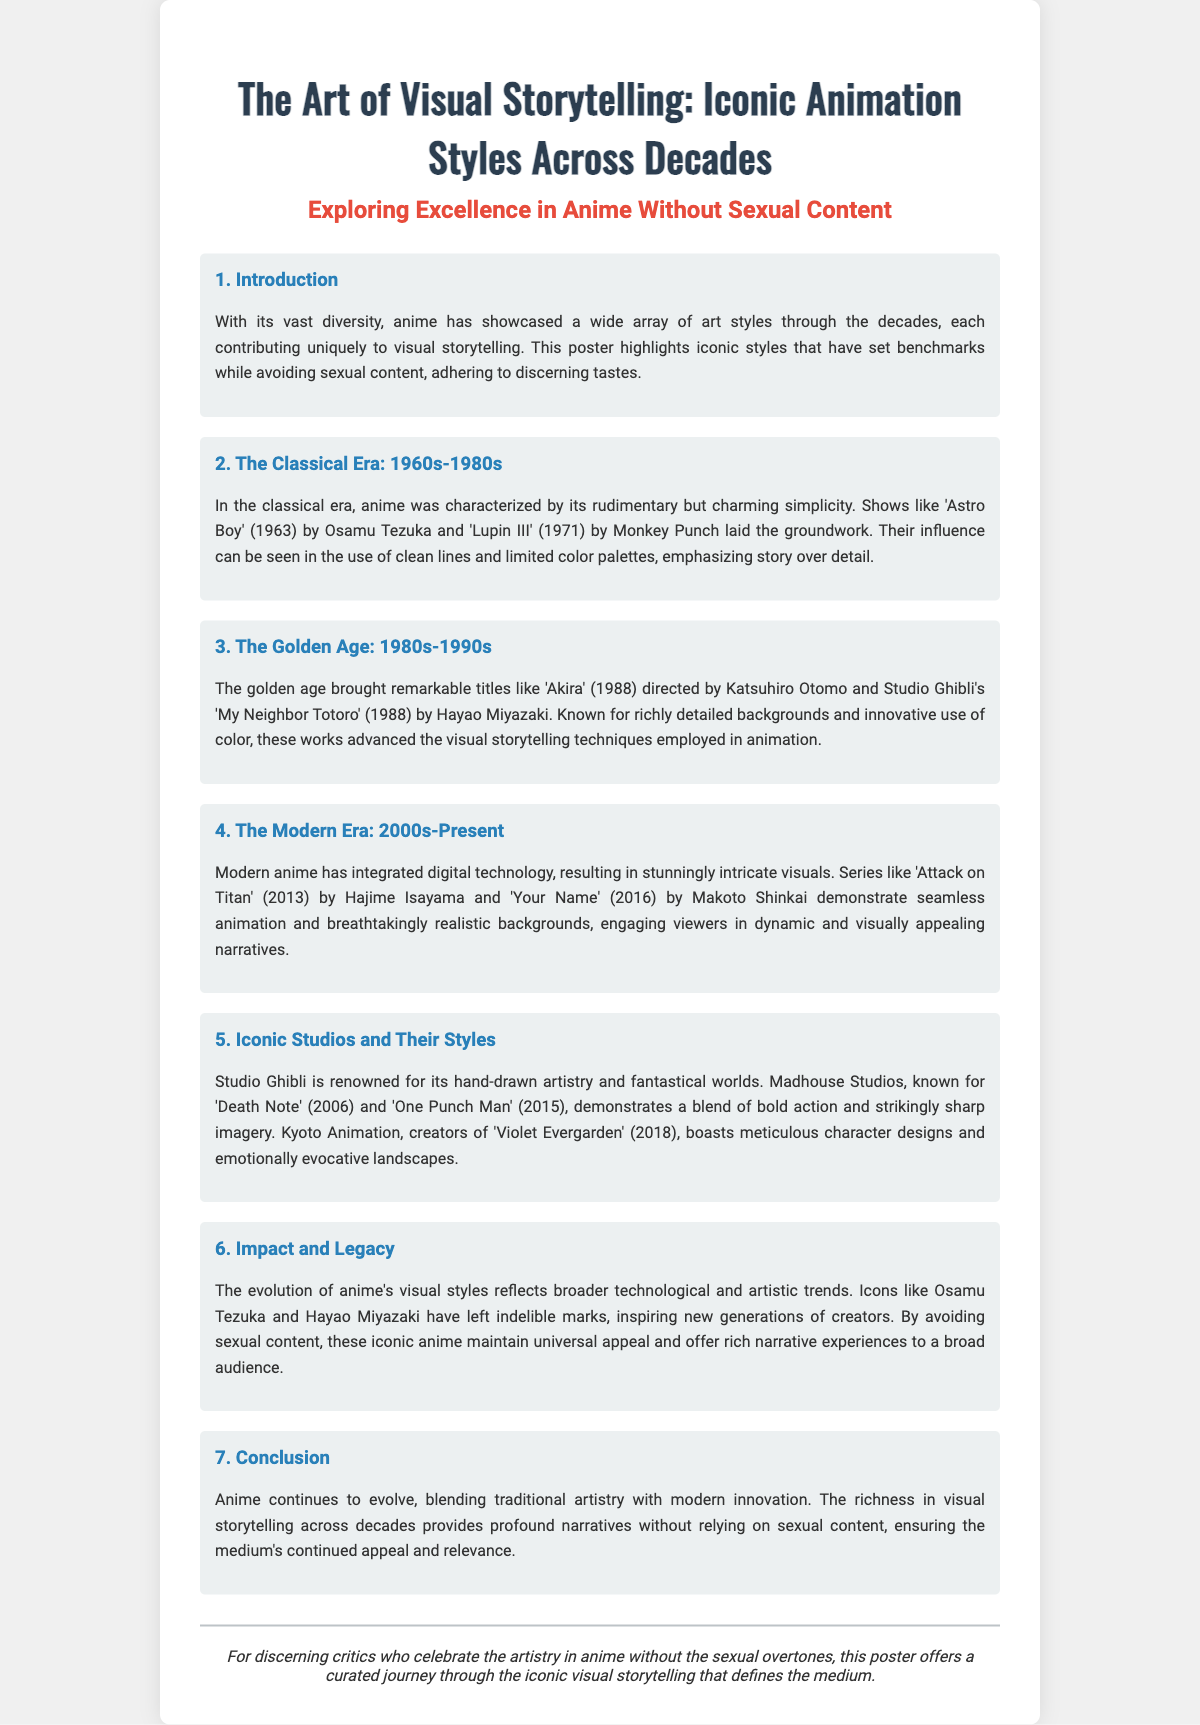What is the title of the poster? The title of the poster is stated at the top of the document.
Answer: The Art of Visual Storytelling: Iconic Animation Styles Across Decades What decades does the classical era cover? The classical era is defined in the section title and content of the poster.
Answer: 1960s-1980s Which iconic anime was directed by Hayao Miyazaki? The poster lists several works associated with Miyazaki, indicating his contribution.
Answer: My Neighbor Totoro What animation technique is Studio Ghibli renowned for? The section discussing iconic studios mentions specific attributes for Ghibli.
Answer: Hand-drawn artistry Who created 'Attack on Titan'? The creator of 'Attack on Titan' is mentioned in the modern era section.
Answer: Hajime Isayama What is a key characteristic of modern anime according to the document? The document discusses advancements in anime style in the modern era.
Answer: Stunningly intricate visuals What is the impact of avoiding sexual content in iconic anime? The poster highlights the effect of content choices on audience appeal.
Answer: Universal appeal What does the document emphasize about anime's evolution? The conclusion section notes the blend of traditional and modern influences.
Answer: Blending traditional artistry with modern innovation 